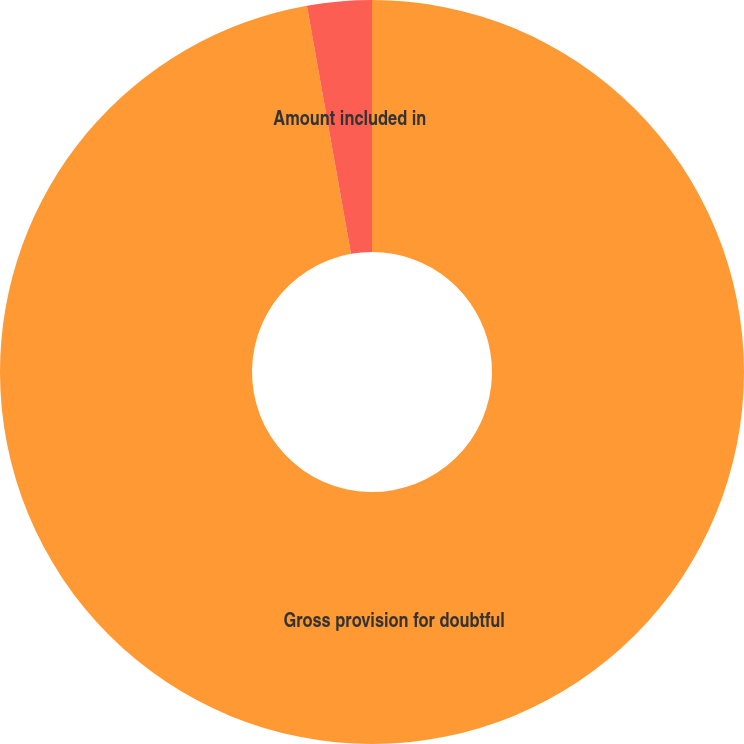<chart> <loc_0><loc_0><loc_500><loc_500><pie_chart><fcel>Gross provision for doubtful<fcel>Amount included in<nl><fcel>97.2%<fcel>2.8%<nl></chart> 